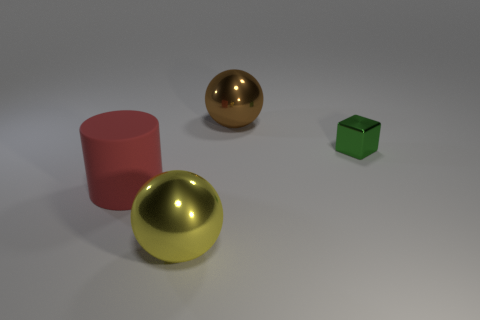Add 2 big brown spheres. How many objects exist? 6 Subtract all blocks. How many objects are left? 3 Add 3 blue shiny objects. How many blue shiny objects exist? 3 Subtract 0 gray balls. How many objects are left? 4 Subtract all big brown metallic balls. Subtract all shiny spheres. How many objects are left? 1 Add 2 yellow balls. How many yellow balls are left? 3 